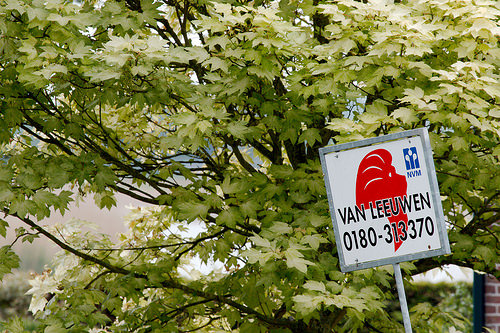<image>
Can you confirm if the tree is behind the sign? Yes. From this viewpoint, the tree is positioned behind the sign, with the sign partially or fully occluding the tree. 